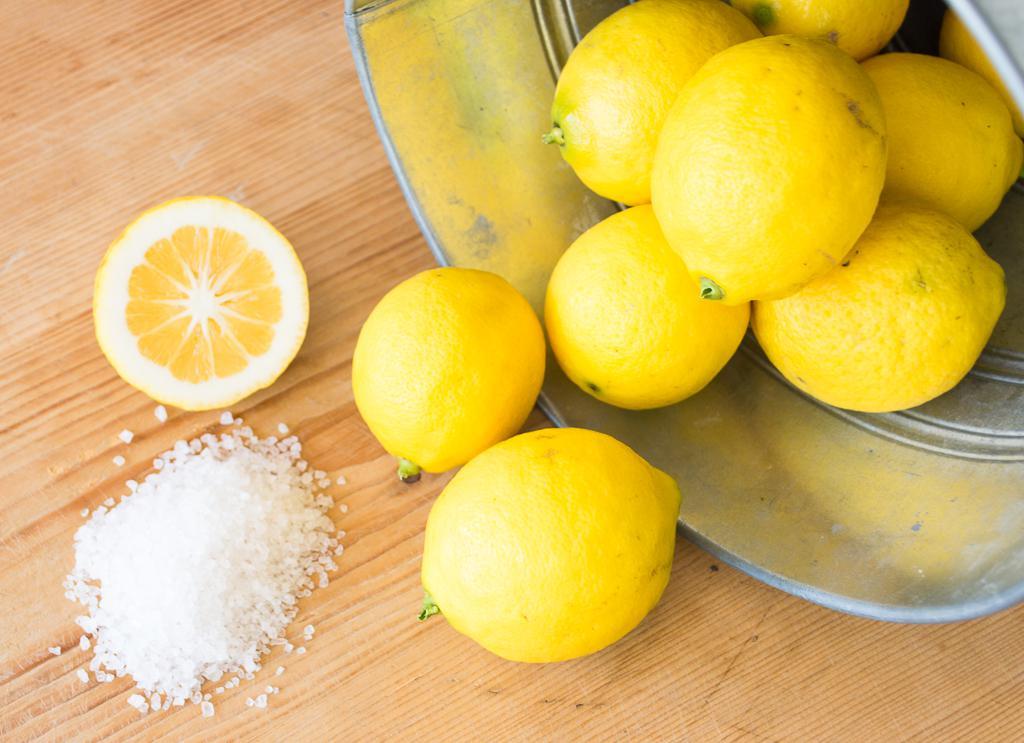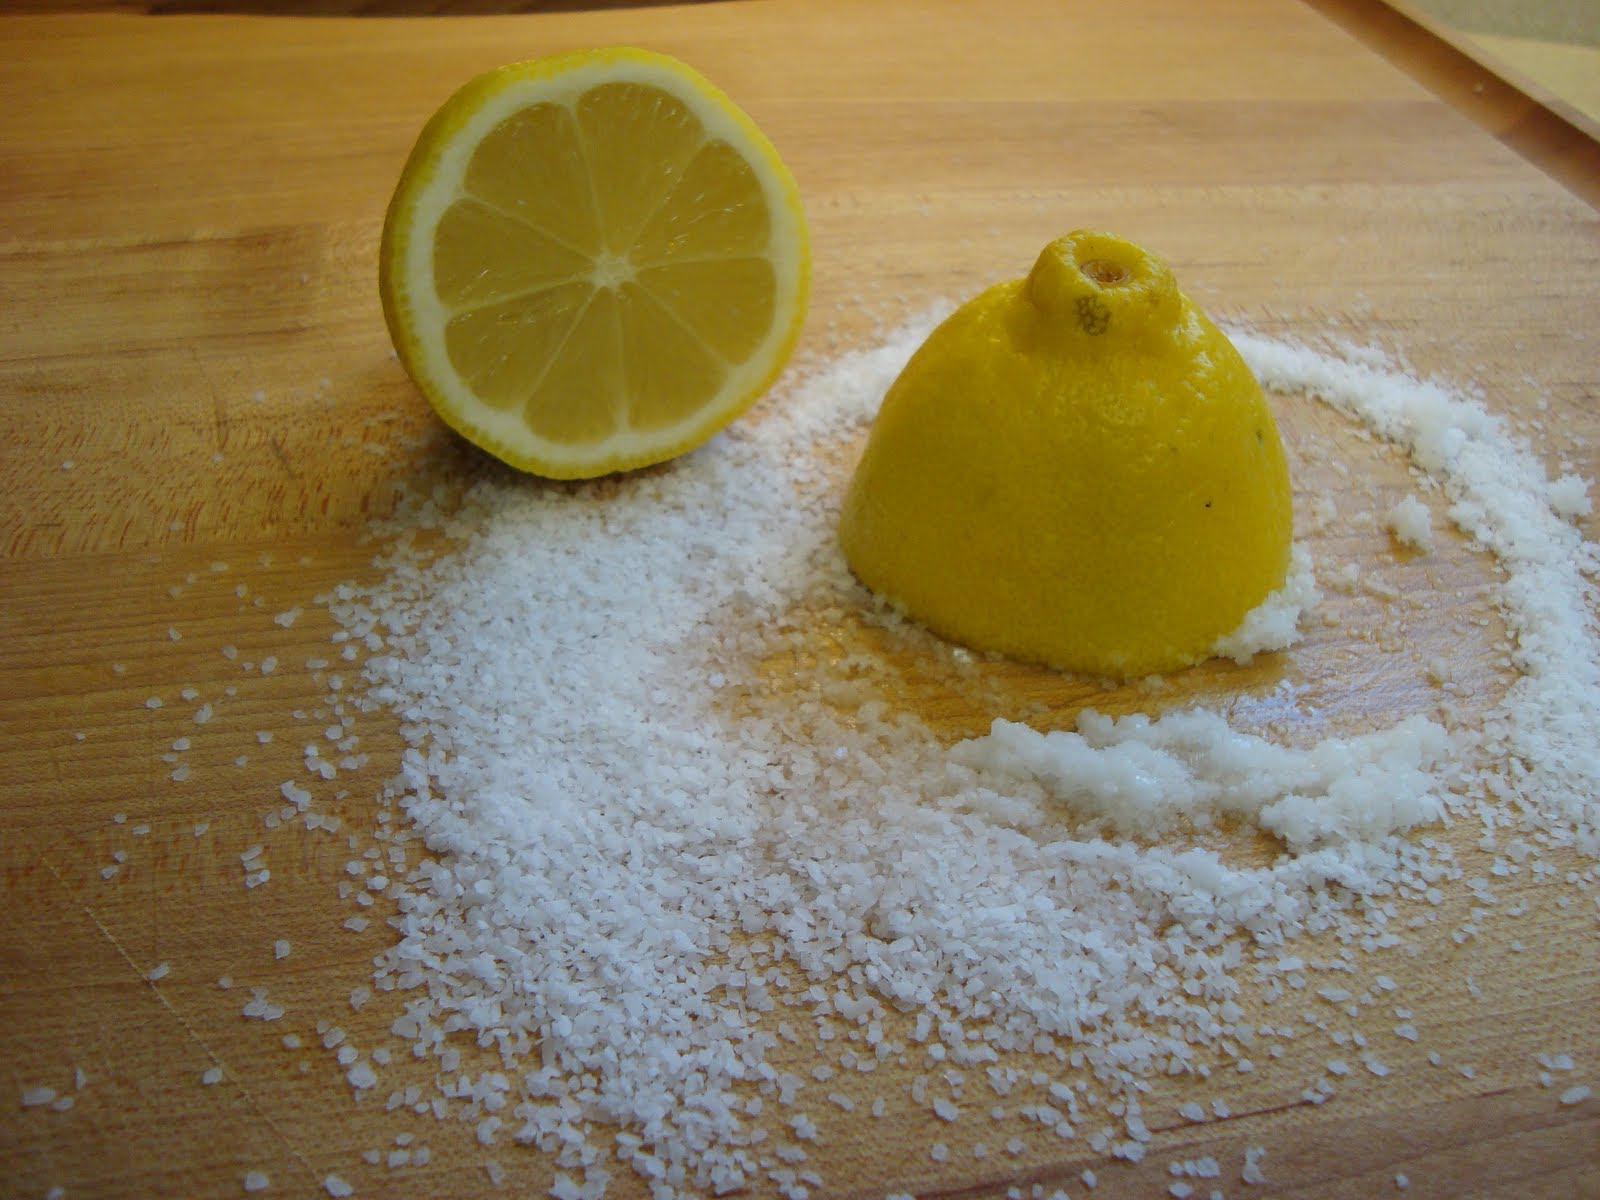The first image is the image on the left, the second image is the image on the right. Given the left and right images, does the statement "The right image shows a lemon cross cut into four parts with salt poured on it." hold true? Answer yes or no. No. The first image is the image on the left, the second image is the image on the right. Considering the images on both sides, is "In one of the images, there is salt next to the lemons but not on any of them." valid? Answer yes or no. Yes. 